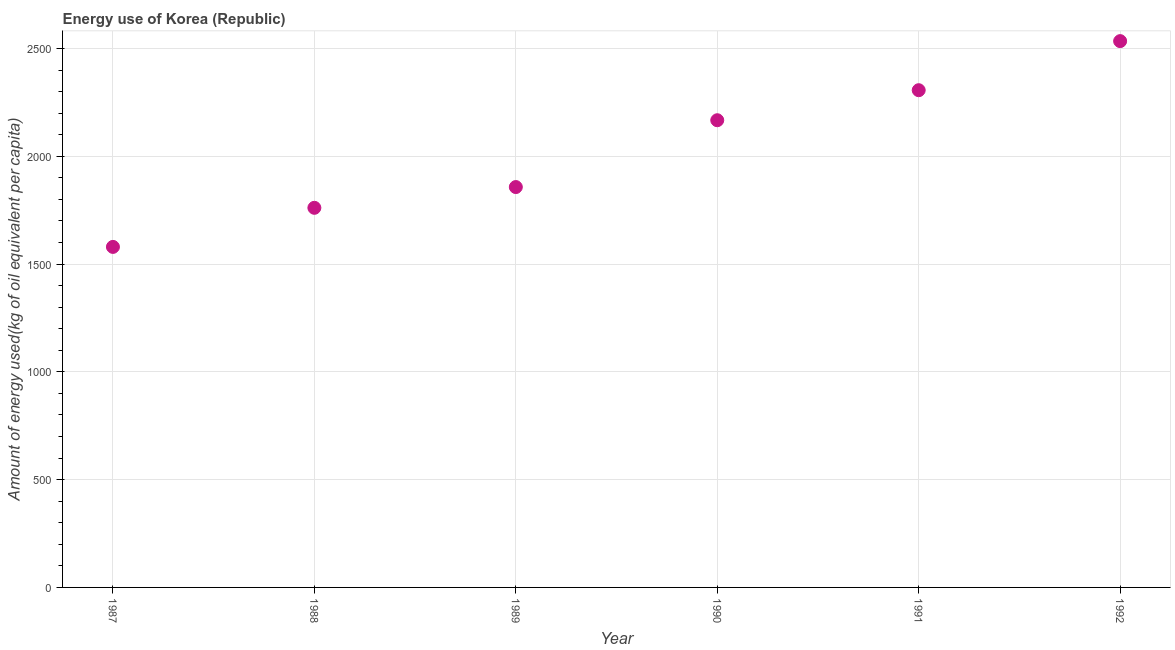What is the amount of energy used in 1992?
Provide a short and direct response. 2534.34. Across all years, what is the maximum amount of energy used?
Ensure brevity in your answer.  2534.34. Across all years, what is the minimum amount of energy used?
Provide a succinct answer. 1579.67. In which year was the amount of energy used maximum?
Provide a short and direct response. 1992. In which year was the amount of energy used minimum?
Provide a short and direct response. 1987. What is the sum of the amount of energy used?
Keep it short and to the point. 1.22e+04. What is the difference between the amount of energy used in 1987 and 1990?
Keep it short and to the point. -587.67. What is the average amount of energy used per year?
Your response must be concise. 2034.38. What is the median amount of energy used?
Your answer should be very brief. 2012.32. Do a majority of the years between 1991 and 1989 (inclusive) have amount of energy used greater than 2100 kg?
Offer a very short reply. No. What is the ratio of the amount of energy used in 1989 to that in 1990?
Keep it short and to the point. 0.86. Is the amount of energy used in 1991 less than that in 1992?
Provide a short and direct response. Yes. What is the difference between the highest and the second highest amount of energy used?
Offer a terse response. 227.7. Is the sum of the amount of energy used in 1989 and 1992 greater than the maximum amount of energy used across all years?
Keep it short and to the point. Yes. What is the difference between the highest and the lowest amount of energy used?
Give a very brief answer. 954.68. In how many years, is the amount of energy used greater than the average amount of energy used taken over all years?
Your answer should be compact. 3. How many dotlines are there?
Make the answer very short. 1. Are the values on the major ticks of Y-axis written in scientific E-notation?
Ensure brevity in your answer.  No. Does the graph contain grids?
Make the answer very short. Yes. What is the title of the graph?
Offer a terse response. Energy use of Korea (Republic). What is the label or title of the X-axis?
Provide a succinct answer. Year. What is the label or title of the Y-axis?
Provide a succinct answer. Amount of energy used(kg of oil equivalent per capita). What is the Amount of energy used(kg of oil equivalent per capita) in 1987?
Ensure brevity in your answer.  1579.67. What is the Amount of energy used(kg of oil equivalent per capita) in 1988?
Provide a short and direct response. 1761.01. What is the Amount of energy used(kg of oil equivalent per capita) in 1989?
Make the answer very short. 1857.3. What is the Amount of energy used(kg of oil equivalent per capita) in 1990?
Offer a terse response. 2167.34. What is the Amount of energy used(kg of oil equivalent per capita) in 1991?
Offer a terse response. 2306.64. What is the Amount of energy used(kg of oil equivalent per capita) in 1992?
Ensure brevity in your answer.  2534.34. What is the difference between the Amount of energy used(kg of oil equivalent per capita) in 1987 and 1988?
Your answer should be very brief. -181.35. What is the difference between the Amount of energy used(kg of oil equivalent per capita) in 1987 and 1989?
Keep it short and to the point. -277.63. What is the difference between the Amount of energy used(kg of oil equivalent per capita) in 1987 and 1990?
Make the answer very short. -587.67. What is the difference between the Amount of energy used(kg of oil equivalent per capita) in 1987 and 1991?
Your answer should be very brief. -726.98. What is the difference between the Amount of energy used(kg of oil equivalent per capita) in 1987 and 1992?
Provide a short and direct response. -954.68. What is the difference between the Amount of energy used(kg of oil equivalent per capita) in 1988 and 1989?
Your response must be concise. -96.28. What is the difference between the Amount of energy used(kg of oil equivalent per capita) in 1988 and 1990?
Your answer should be very brief. -406.32. What is the difference between the Amount of energy used(kg of oil equivalent per capita) in 1988 and 1991?
Keep it short and to the point. -545.63. What is the difference between the Amount of energy used(kg of oil equivalent per capita) in 1988 and 1992?
Ensure brevity in your answer.  -773.33. What is the difference between the Amount of energy used(kg of oil equivalent per capita) in 1989 and 1990?
Offer a very short reply. -310.04. What is the difference between the Amount of energy used(kg of oil equivalent per capita) in 1989 and 1991?
Your answer should be very brief. -449.35. What is the difference between the Amount of energy used(kg of oil equivalent per capita) in 1989 and 1992?
Keep it short and to the point. -677.04. What is the difference between the Amount of energy used(kg of oil equivalent per capita) in 1990 and 1991?
Your answer should be very brief. -139.3. What is the difference between the Amount of energy used(kg of oil equivalent per capita) in 1990 and 1992?
Provide a succinct answer. -367. What is the difference between the Amount of energy used(kg of oil equivalent per capita) in 1991 and 1992?
Your response must be concise. -227.7. What is the ratio of the Amount of energy used(kg of oil equivalent per capita) in 1987 to that in 1988?
Offer a terse response. 0.9. What is the ratio of the Amount of energy used(kg of oil equivalent per capita) in 1987 to that in 1989?
Make the answer very short. 0.85. What is the ratio of the Amount of energy used(kg of oil equivalent per capita) in 1987 to that in 1990?
Keep it short and to the point. 0.73. What is the ratio of the Amount of energy used(kg of oil equivalent per capita) in 1987 to that in 1991?
Give a very brief answer. 0.69. What is the ratio of the Amount of energy used(kg of oil equivalent per capita) in 1987 to that in 1992?
Give a very brief answer. 0.62. What is the ratio of the Amount of energy used(kg of oil equivalent per capita) in 1988 to that in 1989?
Make the answer very short. 0.95. What is the ratio of the Amount of energy used(kg of oil equivalent per capita) in 1988 to that in 1990?
Offer a terse response. 0.81. What is the ratio of the Amount of energy used(kg of oil equivalent per capita) in 1988 to that in 1991?
Offer a very short reply. 0.76. What is the ratio of the Amount of energy used(kg of oil equivalent per capita) in 1988 to that in 1992?
Ensure brevity in your answer.  0.69. What is the ratio of the Amount of energy used(kg of oil equivalent per capita) in 1989 to that in 1990?
Provide a succinct answer. 0.86. What is the ratio of the Amount of energy used(kg of oil equivalent per capita) in 1989 to that in 1991?
Your response must be concise. 0.81. What is the ratio of the Amount of energy used(kg of oil equivalent per capita) in 1989 to that in 1992?
Offer a terse response. 0.73. What is the ratio of the Amount of energy used(kg of oil equivalent per capita) in 1990 to that in 1991?
Offer a very short reply. 0.94. What is the ratio of the Amount of energy used(kg of oil equivalent per capita) in 1990 to that in 1992?
Offer a terse response. 0.85. What is the ratio of the Amount of energy used(kg of oil equivalent per capita) in 1991 to that in 1992?
Your response must be concise. 0.91. 